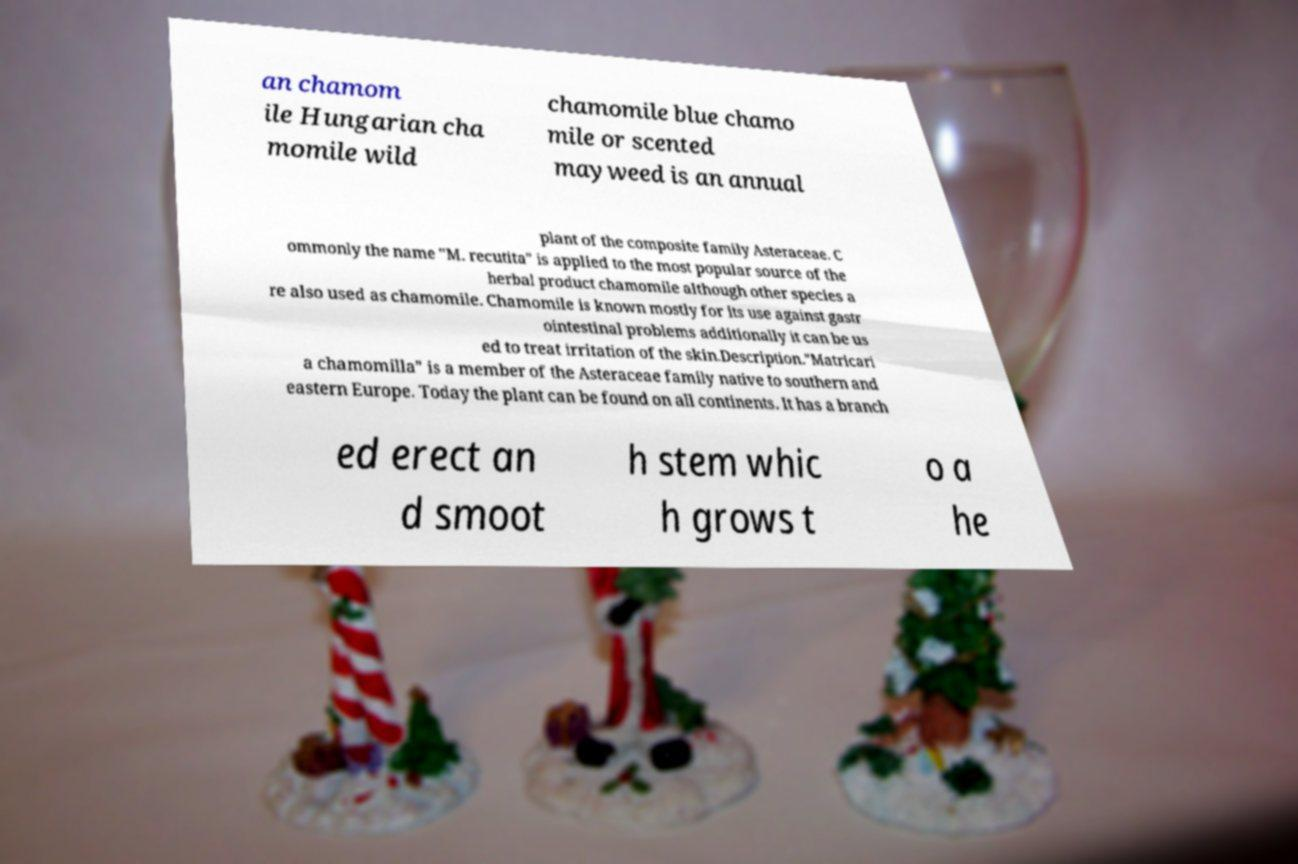Can you read and provide the text displayed in the image?This photo seems to have some interesting text. Can you extract and type it out for me? an chamom ile Hungarian cha momile wild chamomile blue chamo mile or scented mayweed is an annual plant of the composite family Asteraceae. C ommonly the name "M. recutita" is applied to the most popular source of the herbal product chamomile although other species a re also used as chamomile. Chamomile is known mostly for its use against gastr ointestinal problems additionally it can be us ed to treat irritation of the skin.Description."Matricari a chamomilla" is a member of the Asteraceae family native to southern and eastern Europe. Today the plant can be found on all continents. It has a branch ed erect an d smoot h stem whic h grows t o a he 